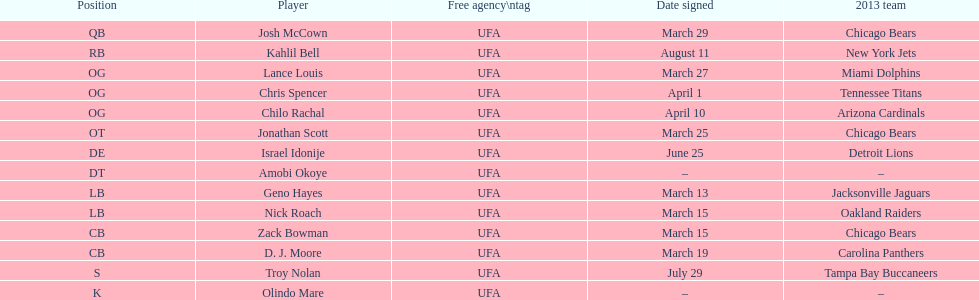Who was the player signed just before troy nolan? Israel Idonije. 